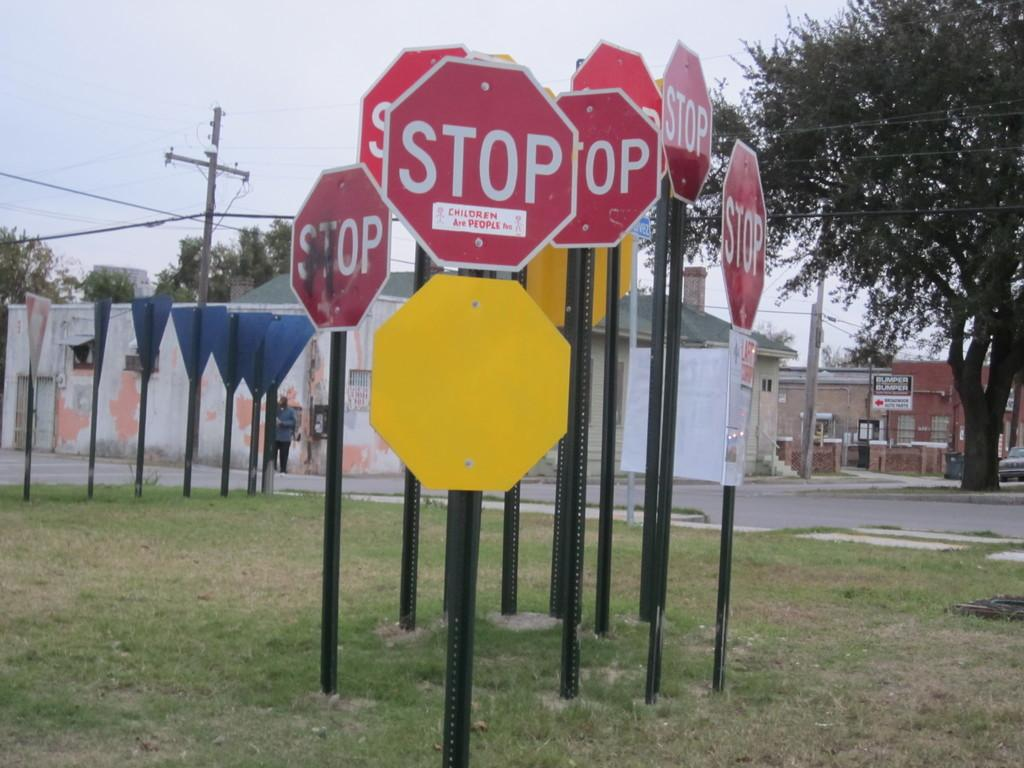<image>
Summarize the visual content of the image. A cluster of stop signs one of which has a sticker on it that says children are people. 